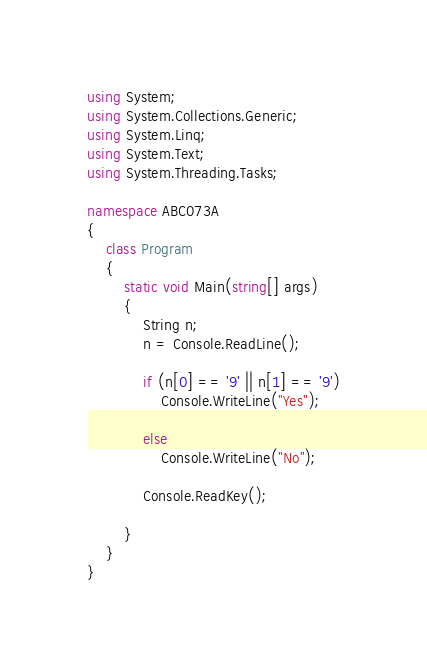Convert code to text. <code><loc_0><loc_0><loc_500><loc_500><_C#_>using System;
using System.Collections.Generic;
using System.Linq;
using System.Text;
using System.Threading.Tasks;

namespace ABC073A
{
    class Program
    {
        static void Main(string[] args)
        {
            String n;
            n = Console.ReadLine();

            if (n[0] == '9' || n[1] == '9')
                Console.WriteLine("Yes");

            else
                Console.WriteLine("No");

            Console.ReadKey();

        }
    }
}
</code> 